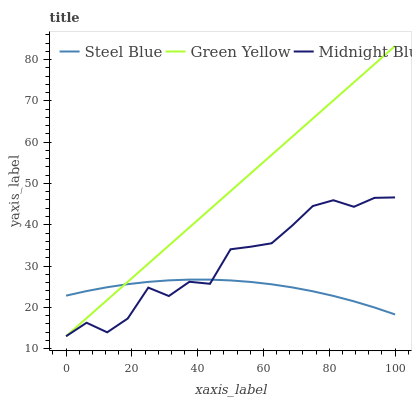Does Steel Blue have the minimum area under the curve?
Answer yes or no. Yes. Does Green Yellow have the maximum area under the curve?
Answer yes or no. Yes. Does Midnight Blue have the minimum area under the curve?
Answer yes or no. No. Does Midnight Blue have the maximum area under the curve?
Answer yes or no. No. Is Green Yellow the smoothest?
Answer yes or no. Yes. Is Midnight Blue the roughest?
Answer yes or no. Yes. Is Steel Blue the smoothest?
Answer yes or no. No. Is Steel Blue the roughest?
Answer yes or no. No. Does Green Yellow have the lowest value?
Answer yes or no. Yes. Does Steel Blue have the lowest value?
Answer yes or no. No. Does Green Yellow have the highest value?
Answer yes or no. Yes. Does Midnight Blue have the highest value?
Answer yes or no. No. Does Midnight Blue intersect Steel Blue?
Answer yes or no. Yes. Is Midnight Blue less than Steel Blue?
Answer yes or no. No. Is Midnight Blue greater than Steel Blue?
Answer yes or no. No. 